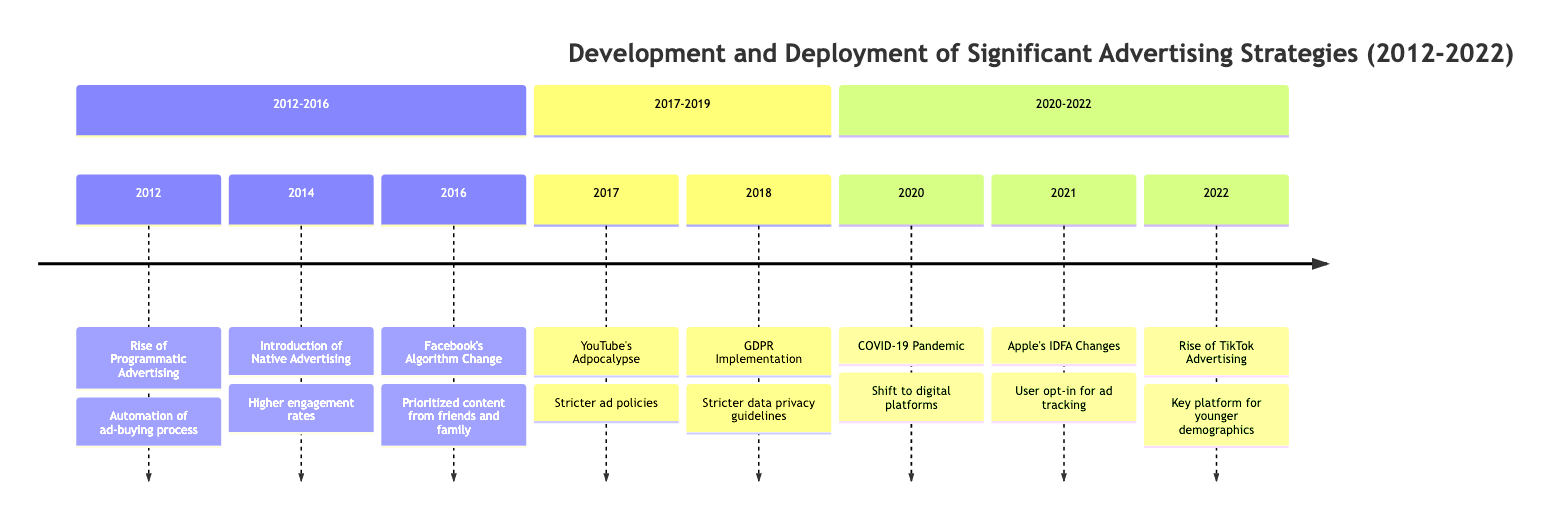What event happened in 2012? The diagram indicates that in 2012, the event that occurred was the "Rise of Programmatic Advertising."
Answer: Rise of Programmatic Advertising How many major events are listed in the timeline? By counting the number of events presented in the timeline, we find there are eight significant events mentioned.
Answer: 8 Which advertising strategy was introduced in 2014? According to the timeline, the event for 2014 is the "Introduction of Native Advertising."
Answer: Introduction of Native Advertising How did the COVID-19 pandemic affect advertising strategies? The timeline shows that in 2020, the shift in advertising strategies was to focus more on digital platforms due to increased online activity.
Answer: Shift to digital platforms What significant change occurred due to Apple's IDFA in 2021? The diagram notes that the iOS 14.5 update required users to opt-in for ad tracking, which significantly impacted personalized advertising effectiveness.
Answer: User opt-in for ad tracking How did GDPR impact advertising in 2018? The timeline indicates that in 2018, the GDPR Implementation enforced stricter data privacy guidelines that advertisers needed to adapt to.
Answer: Stricter data privacy guidelines In which year did the rise of TikTok advertising occur? The timeline shows that marketers heavily invested in TikTok advertising starting in 2022.
Answer: 2022 What was the primary focus of advertising strategies during the COVID-19 pandemic? According to the timeline, the primary focus shifted to digital platforms due to increased online consumption during the COVID-19 pandemic.
Answer: Digital platforms What was affected by Facebook's algorithm change in 2016? The timeline points out that Facebook's algorithm change in 2016 prioritized content from friends and family over publishers, affecting the reach of branded content.
Answer: Reach of branded content 